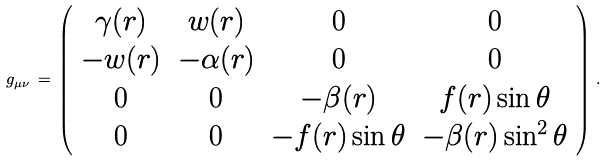Convert formula to latex. <formula><loc_0><loc_0><loc_500><loc_500>g _ { \mu \nu } \, = \, \left ( \begin{array} { c c c c } \gamma ( r ) & w ( r ) & 0 & 0 \\ - w ( r ) & - \alpha ( r ) & 0 & 0 \\ 0 & 0 & - \beta ( r ) & f ( r ) \sin \theta \\ 0 & 0 & - f ( r ) \sin \theta & - \beta ( r ) \sin ^ { 2 } \theta \end{array} \right ) \, .</formula> 